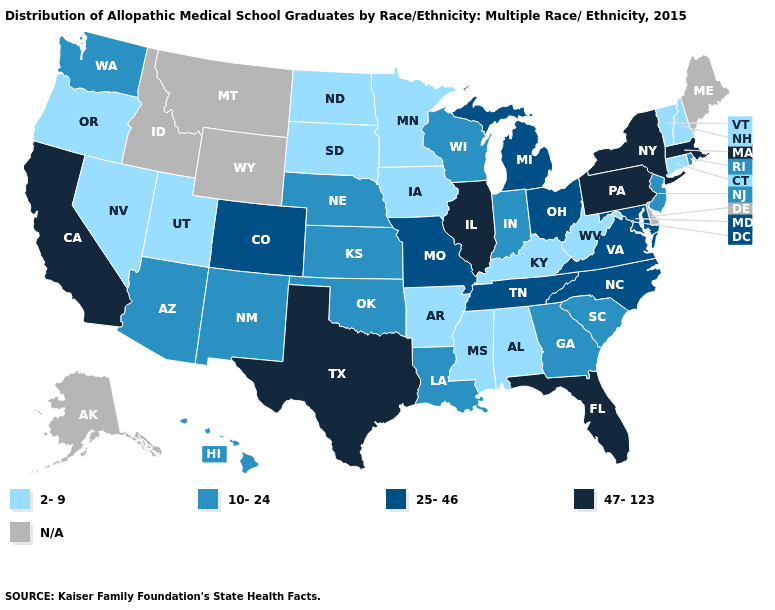Among the states that border Idaho , which have the highest value?
Be succinct. Washington. Does Rhode Island have the highest value in the Northeast?
Concise answer only. No. What is the lowest value in the USA?
Give a very brief answer. 2-9. Name the states that have a value in the range 10-24?
Give a very brief answer. Arizona, Georgia, Hawaii, Indiana, Kansas, Louisiana, Nebraska, New Jersey, New Mexico, Oklahoma, Rhode Island, South Carolina, Washington, Wisconsin. What is the value of Arkansas?
Answer briefly. 2-9. What is the lowest value in the South?
Concise answer only. 2-9. What is the value of New Hampshire?
Answer briefly. 2-9. Name the states that have a value in the range 2-9?
Quick response, please. Alabama, Arkansas, Connecticut, Iowa, Kentucky, Minnesota, Mississippi, Nevada, New Hampshire, North Dakota, Oregon, South Dakota, Utah, Vermont, West Virginia. Which states have the lowest value in the USA?
Short answer required. Alabama, Arkansas, Connecticut, Iowa, Kentucky, Minnesota, Mississippi, Nevada, New Hampshire, North Dakota, Oregon, South Dakota, Utah, Vermont, West Virginia. Does Louisiana have the highest value in the USA?
Give a very brief answer. No. Among the states that border Louisiana , which have the highest value?
Give a very brief answer. Texas. What is the highest value in the Northeast ?
Short answer required. 47-123. Among the states that border Virginia , does Tennessee have the highest value?
Keep it brief. Yes. What is the highest value in states that border Arizona?
Be succinct. 47-123. 